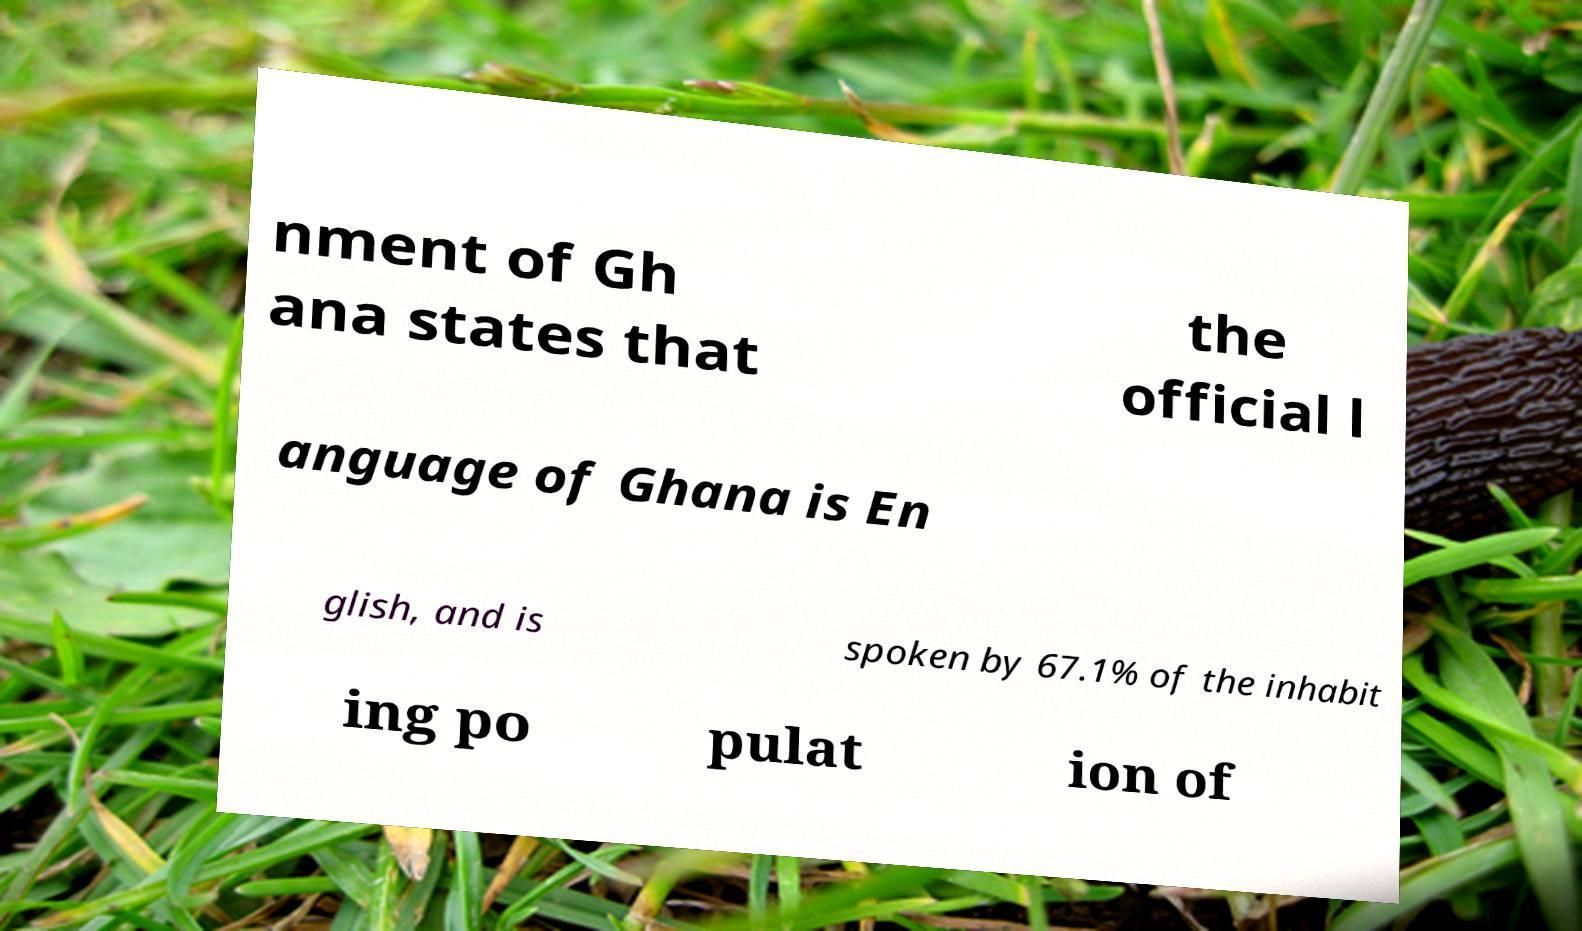Please identify and transcribe the text found in this image. nment of Gh ana states that the official l anguage of Ghana is En glish, and is spoken by 67.1% of the inhabit ing po pulat ion of 